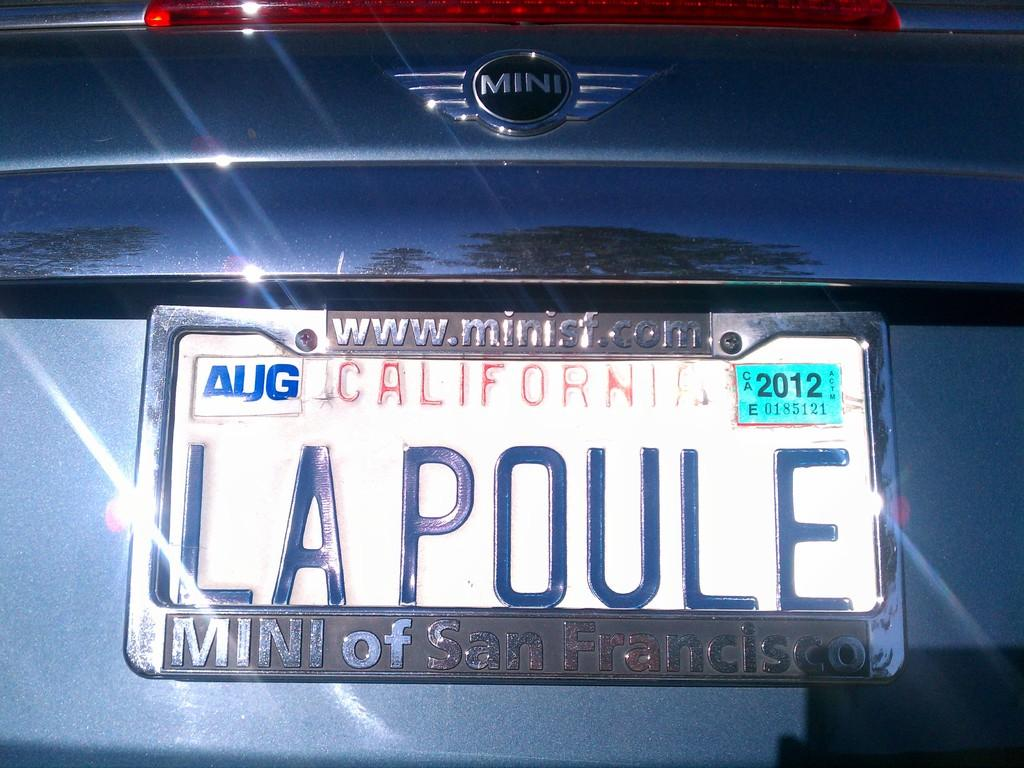<image>
Relay a brief, clear account of the picture shown. The back of a car that was purchased in San Francisco. 